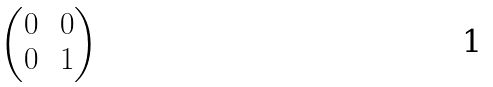Convert formula to latex. <formula><loc_0><loc_0><loc_500><loc_500>\begin{pmatrix} 0 \, & 0 \\ 0 \, & 1 \end{pmatrix}</formula> 